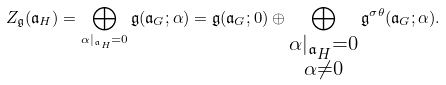Convert formula to latex. <formula><loc_0><loc_0><loc_500><loc_500>Z _ { \mathfrak { g } } ( { \mathfrak { a } } _ { H } ) = \bigoplus _ { \alpha | _ { { \mathfrak { a } } _ { H } } = 0 } { \mathfrak { g } } ( { \mathfrak { a } } _ { G } ; \alpha ) = { \mathfrak { g } } ( { \mathfrak { a } } _ { G } ; 0 ) \oplus \bigoplus _ { \substack { \alpha | _ { { \mathfrak { a } } _ { H } } = 0 \\ \alpha \ne 0 } } { \mathfrak { g } } ^ { \sigma \theta } ( { \mathfrak { a } } _ { G } ; \alpha ) .</formula> 